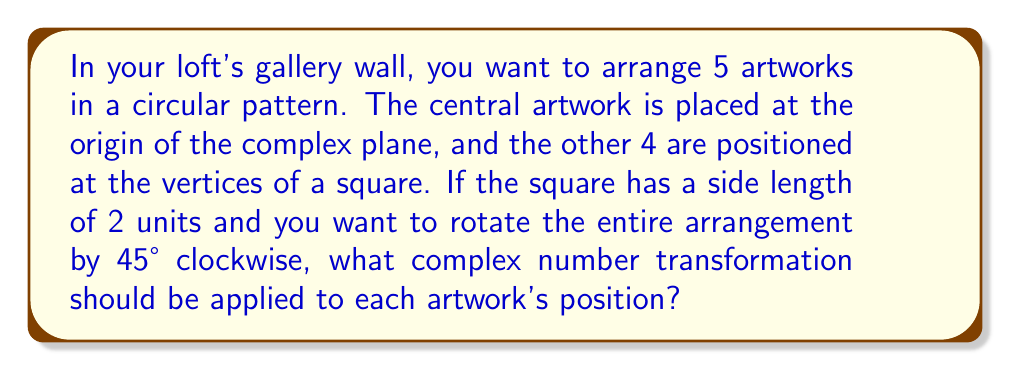Could you help me with this problem? Let's approach this step-by-step:

1) First, we need to identify the initial positions of the artworks. The central artwork is at the origin (0,0) or 0 in the complex plane. The other four artworks form a square with side length 2, centered at the origin. Their positions can be represented as:

   $1+i$, $1-i$, $-1+i$, $-1-i$

2) To rotate by 45° clockwise, we need to multiply each position by $e^{-i\pi/4}$. This is because:
   - Counterclockwise rotation by $\theta$ is given by $e^{i\theta}$
   - We want clockwise rotation, so we use $-\theta$
   - 45° = $\pi/4$ radians

3) The transformation we need to apply is:

   $z \mapsto z \cdot e^{-i\pi/4}$

4) We can simplify $e^{-i\pi/4}$:
   
   $e^{-i\pi/4} = \cos(-\pi/4) + i\sin(-\pi/4) = \frac{\sqrt{2}}{2} - i\frac{\sqrt{2}}{2}$

5) Therefore, the final transformation is:

   $z \mapsto z \cdot (\frac{\sqrt{2}}{2} - i\frac{\sqrt{2}}{2})$

This transformation will rotate each artwork's position by 45° clockwise around the origin, maintaining their relative positions and the overall circular arrangement.
Answer: $z \mapsto z \cdot (\frac{\sqrt{2}}{2} - i\frac{\sqrt{2}}{2})$ 